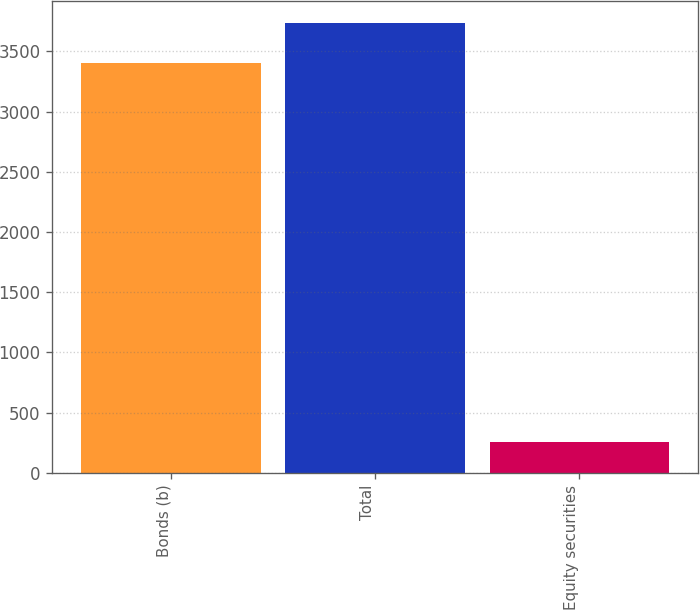Convert chart. <chart><loc_0><loc_0><loc_500><loc_500><bar_chart><fcel>Bonds (b)<fcel>Total<fcel>Equity securities<nl><fcel>3403<fcel>3733.5<fcel>257<nl></chart> 